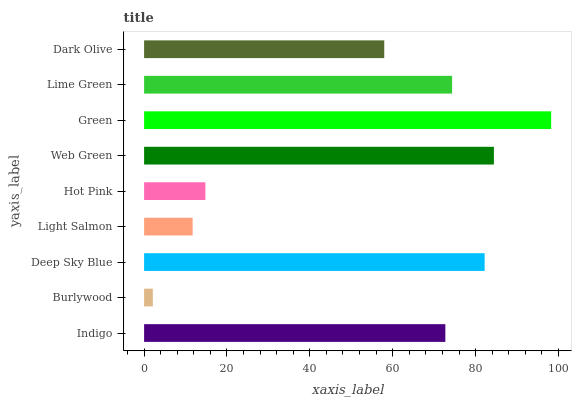Is Burlywood the minimum?
Answer yes or no. Yes. Is Green the maximum?
Answer yes or no. Yes. Is Deep Sky Blue the minimum?
Answer yes or no. No. Is Deep Sky Blue the maximum?
Answer yes or no. No. Is Deep Sky Blue greater than Burlywood?
Answer yes or no. Yes. Is Burlywood less than Deep Sky Blue?
Answer yes or no. Yes. Is Burlywood greater than Deep Sky Blue?
Answer yes or no. No. Is Deep Sky Blue less than Burlywood?
Answer yes or no. No. Is Indigo the high median?
Answer yes or no. Yes. Is Indigo the low median?
Answer yes or no. Yes. Is Deep Sky Blue the high median?
Answer yes or no. No. Is Dark Olive the low median?
Answer yes or no. No. 